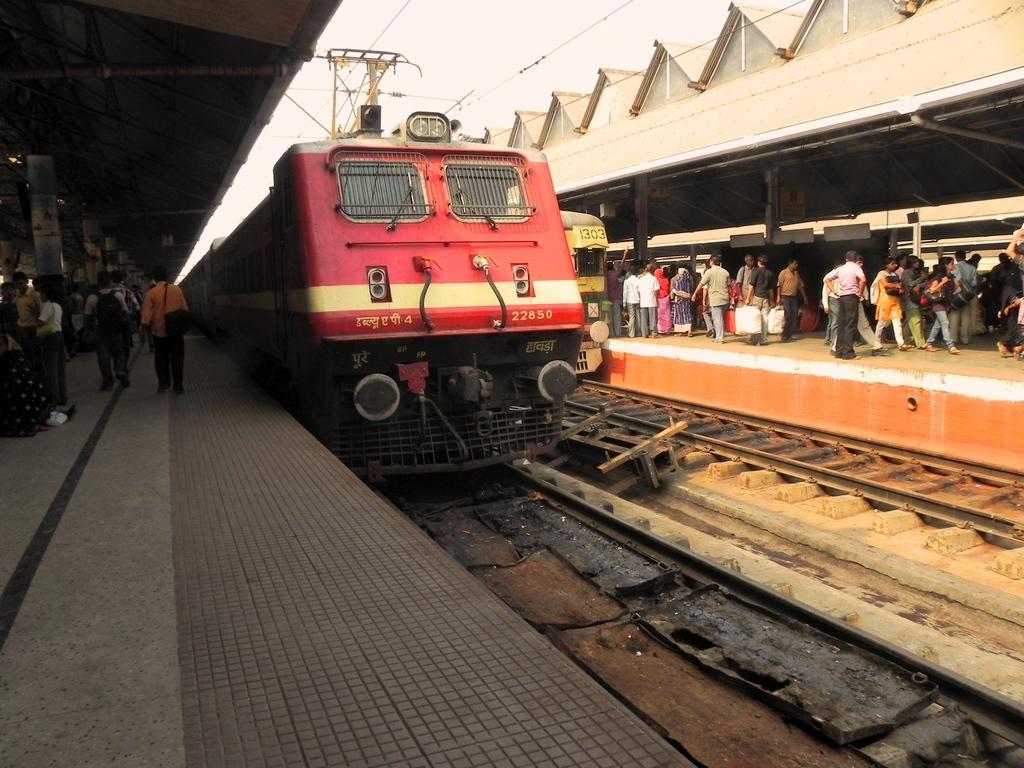Could you give a brief overview of what you see in this image? In the foreground of this image, there is a train on the track. On either side, there are platforms on which there are people walking. At the top, there are sheds, cables and the sky. 